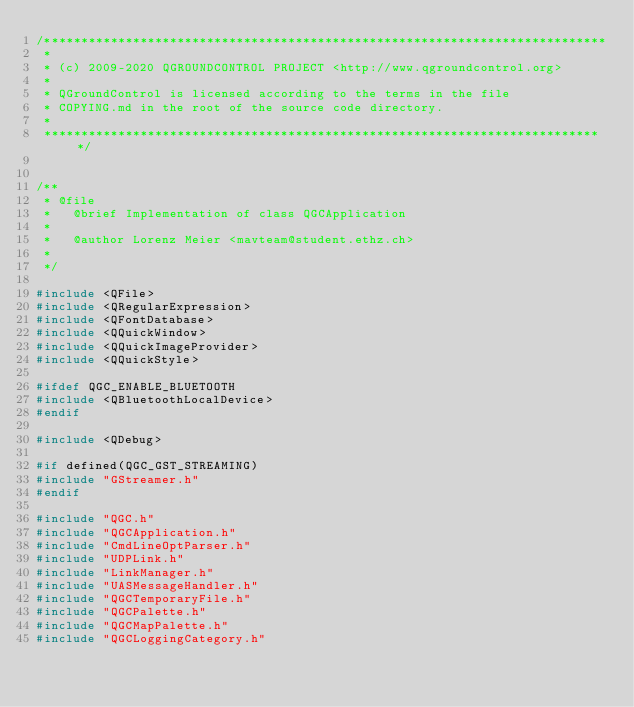Convert code to text. <code><loc_0><loc_0><loc_500><loc_500><_C++_>/****************************************************************************
 *
 * (c) 2009-2020 QGROUNDCONTROL PROJECT <http://www.qgroundcontrol.org>
 *
 * QGroundControl is licensed according to the terms in the file
 * COPYING.md in the root of the source code directory.
 *
 ****************************************************************************/


/**
 * @file
 *   @brief Implementation of class QGCApplication
 *
 *   @author Lorenz Meier <mavteam@student.ethz.ch>
 *
 */

#include <QFile>
#include <QRegularExpression>
#include <QFontDatabase>
#include <QQuickWindow>
#include <QQuickImageProvider>
#include <QQuickStyle>

#ifdef QGC_ENABLE_BLUETOOTH
#include <QBluetoothLocalDevice>
#endif

#include <QDebug>

#if defined(QGC_GST_STREAMING)
#include "GStreamer.h"
#endif

#include "QGC.h"
#include "QGCApplication.h"
#include "CmdLineOptParser.h"
#include "UDPLink.h"
#include "LinkManager.h"
#include "UASMessageHandler.h"
#include "QGCTemporaryFile.h"
#include "QGCPalette.h"
#include "QGCMapPalette.h"
#include "QGCLoggingCategory.h"</code> 